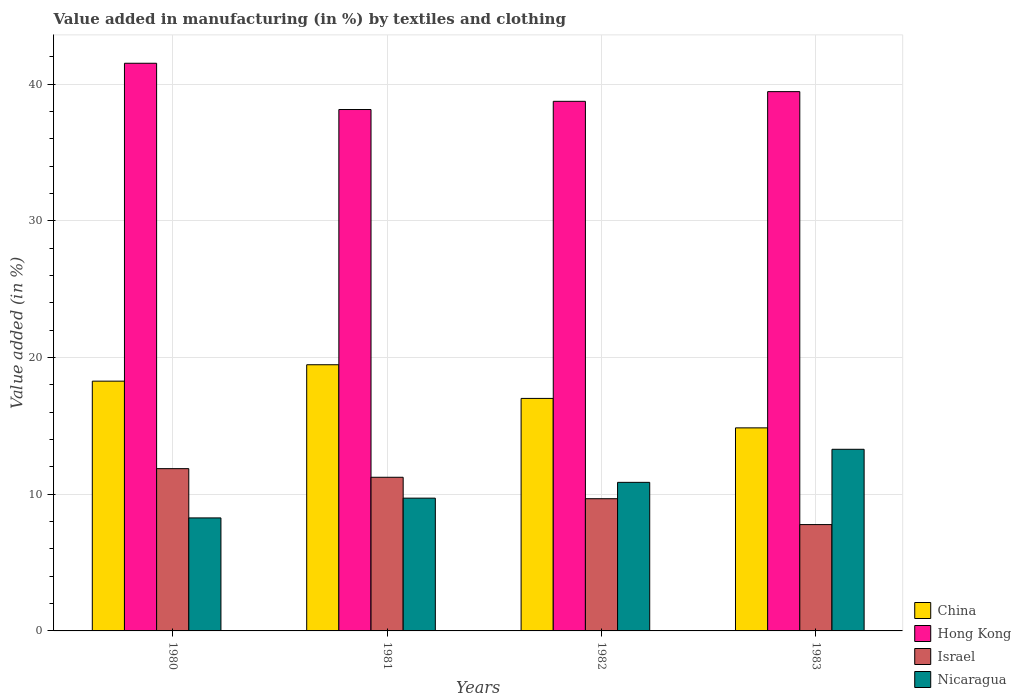How many different coloured bars are there?
Provide a short and direct response. 4. Are the number of bars on each tick of the X-axis equal?
Offer a terse response. Yes. How many bars are there on the 1st tick from the right?
Provide a succinct answer. 4. What is the label of the 1st group of bars from the left?
Offer a terse response. 1980. What is the percentage of value added in manufacturing by textiles and clothing in Nicaragua in 1983?
Make the answer very short. 13.29. Across all years, what is the maximum percentage of value added in manufacturing by textiles and clothing in Nicaragua?
Your answer should be very brief. 13.29. Across all years, what is the minimum percentage of value added in manufacturing by textiles and clothing in Israel?
Offer a terse response. 7.78. In which year was the percentage of value added in manufacturing by textiles and clothing in China maximum?
Give a very brief answer. 1981. In which year was the percentage of value added in manufacturing by textiles and clothing in Hong Kong minimum?
Offer a very short reply. 1981. What is the total percentage of value added in manufacturing by textiles and clothing in Israel in the graph?
Provide a short and direct response. 40.57. What is the difference between the percentage of value added in manufacturing by textiles and clothing in Israel in 1982 and that in 1983?
Provide a short and direct response. 1.89. What is the difference between the percentage of value added in manufacturing by textiles and clothing in Nicaragua in 1982 and the percentage of value added in manufacturing by textiles and clothing in Hong Kong in 1980?
Ensure brevity in your answer.  -30.66. What is the average percentage of value added in manufacturing by textiles and clothing in Israel per year?
Your answer should be very brief. 10.14. In the year 1981, what is the difference between the percentage of value added in manufacturing by textiles and clothing in Hong Kong and percentage of value added in manufacturing by textiles and clothing in Nicaragua?
Offer a terse response. 28.43. What is the ratio of the percentage of value added in manufacturing by textiles and clothing in Israel in 1982 to that in 1983?
Ensure brevity in your answer.  1.24. What is the difference between the highest and the second highest percentage of value added in manufacturing by textiles and clothing in Hong Kong?
Give a very brief answer. 2.08. What is the difference between the highest and the lowest percentage of value added in manufacturing by textiles and clothing in Nicaragua?
Keep it short and to the point. 5.02. In how many years, is the percentage of value added in manufacturing by textiles and clothing in Israel greater than the average percentage of value added in manufacturing by textiles and clothing in Israel taken over all years?
Give a very brief answer. 2. Is the sum of the percentage of value added in manufacturing by textiles and clothing in Israel in 1980 and 1981 greater than the maximum percentage of value added in manufacturing by textiles and clothing in Nicaragua across all years?
Your answer should be compact. Yes. Is it the case that in every year, the sum of the percentage of value added in manufacturing by textiles and clothing in China and percentage of value added in manufacturing by textiles and clothing in Hong Kong is greater than the sum of percentage of value added in manufacturing by textiles and clothing in Israel and percentage of value added in manufacturing by textiles and clothing in Nicaragua?
Your answer should be compact. Yes. What does the 1st bar from the left in 1982 represents?
Keep it short and to the point. China. What does the 2nd bar from the right in 1980 represents?
Offer a terse response. Israel. How many bars are there?
Provide a succinct answer. 16. How many years are there in the graph?
Offer a terse response. 4. Does the graph contain any zero values?
Offer a terse response. No. Does the graph contain grids?
Offer a terse response. Yes. Where does the legend appear in the graph?
Provide a succinct answer. Bottom right. How many legend labels are there?
Ensure brevity in your answer.  4. What is the title of the graph?
Provide a short and direct response. Value added in manufacturing (in %) by textiles and clothing. What is the label or title of the Y-axis?
Offer a very short reply. Value added (in %). What is the Value added (in %) of China in 1980?
Provide a short and direct response. 18.27. What is the Value added (in %) of Hong Kong in 1980?
Make the answer very short. 41.53. What is the Value added (in %) of Israel in 1980?
Offer a terse response. 11.87. What is the Value added (in %) of Nicaragua in 1980?
Keep it short and to the point. 8.27. What is the Value added (in %) of China in 1981?
Provide a succinct answer. 19.47. What is the Value added (in %) of Hong Kong in 1981?
Make the answer very short. 38.15. What is the Value added (in %) in Israel in 1981?
Give a very brief answer. 11.24. What is the Value added (in %) in Nicaragua in 1981?
Provide a short and direct response. 9.71. What is the Value added (in %) in China in 1982?
Your response must be concise. 17.01. What is the Value added (in %) of Hong Kong in 1982?
Give a very brief answer. 38.75. What is the Value added (in %) of Israel in 1982?
Your response must be concise. 9.67. What is the Value added (in %) in Nicaragua in 1982?
Keep it short and to the point. 10.87. What is the Value added (in %) of China in 1983?
Keep it short and to the point. 14.86. What is the Value added (in %) in Hong Kong in 1983?
Provide a short and direct response. 39.46. What is the Value added (in %) in Israel in 1983?
Offer a terse response. 7.78. What is the Value added (in %) in Nicaragua in 1983?
Your answer should be very brief. 13.29. Across all years, what is the maximum Value added (in %) of China?
Your answer should be very brief. 19.47. Across all years, what is the maximum Value added (in %) of Hong Kong?
Your answer should be very brief. 41.53. Across all years, what is the maximum Value added (in %) of Israel?
Your answer should be very brief. 11.87. Across all years, what is the maximum Value added (in %) in Nicaragua?
Your response must be concise. 13.29. Across all years, what is the minimum Value added (in %) in China?
Offer a very short reply. 14.86. Across all years, what is the minimum Value added (in %) in Hong Kong?
Provide a succinct answer. 38.15. Across all years, what is the minimum Value added (in %) of Israel?
Give a very brief answer. 7.78. Across all years, what is the minimum Value added (in %) in Nicaragua?
Ensure brevity in your answer.  8.27. What is the total Value added (in %) of China in the graph?
Your response must be concise. 69.61. What is the total Value added (in %) of Hong Kong in the graph?
Give a very brief answer. 157.88. What is the total Value added (in %) in Israel in the graph?
Offer a terse response. 40.57. What is the total Value added (in %) in Nicaragua in the graph?
Give a very brief answer. 42.14. What is the difference between the Value added (in %) of China in 1980 and that in 1981?
Your answer should be very brief. -1.2. What is the difference between the Value added (in %) of Hong Kong in 1980 and that in 1981?
Make the answer very short. 3.38. What is the difference between the Value added (in %) in Israel in 1980 and that in 1981?
Provide a short and direct response. 0.63. What is the difference between the Value added (in %) of Nicaragua in 1980 and that in 1981?
Provide a short and direct response. -1.45. What is the difference between the Value added (in %) in China in 1980 and that in 1982?
Your answer should be compact. 1.26. What is the difference between the Value added (in %) of Hong Kong in 1980 and that in 1982?
Keep it short and to the point. 2.78. What is the difference between the Value added (in %) in Israel in 1980 and that in 1982?
Keep it short and to the point. 2.2. What is the difference between the Value added (in %) in Nicaragua in 1980 and that in 1982?
Your answer should be very brief. -2.6. What is the difference between the Value added (in %) in China in 1980 and that in 1983?
Give a very brief answer. 3.42. What is the difference between the Value added (in %) in Hong Kong in 1980 and that in 1983?
Provide a succinct answer. 2.08. What is the difference between the Value added (in %) of Israel in 1980 and that in 1983?
Give a very brief answer. 4.09. What is the difference between the Value added (in %) of Nicaragua in 1980 and that in 1983?
Your answer should be compact. -5.02. What is the difference between the Value added (in %) in China in 1981 and that in 1982?
Make the answer very short. 2.46. What is the difference between the Value added (in %) of Hong Kong in 1981 and that in 1982?
Offer a very short reply. -0.6. What is the difference between the Value added (in %) of Israel in 1981 and that in 1982?
Make the answer very short. 1.57. What is the difference between the Value added (in %) of Nicaragua in 1981 and that in 1982?
Provide a short and direct response. -1.16. What is the difference between the Value added (in %) in China in 1981 and that in 1983?
Keep it short and to the point. 4.62. What is the difference between the Value added (in %) of Hong Kong in 1981 and that in 1983?
Provide a short and direct response. -1.31. What is the difference between the Value added (in %) in Israel in 1981 and that in 1983?
Offer a terse response. 3.46. What is the difference between the Value added (in %) of Nicaragua in 1981 and that in 1983?
Your answer should be compact. -3.57. What is the difference between the Value added (in %) in China in 1982 and that in 1983?
Offer a very short reply. 2.16. What is the difference between the Value added (in %) in Hong Kong in 1982 and that in 1983?
Provide a succinct answer. -0.71. What is the difference between the Value added (in %) in Israel in 1982 and that in 1983?
Offer a very short reply. 1.89. What is the difference between the Value added (in %) of Nicaragua in 1982 and that in 1983?
Give a very brief answer. -2.42. What is the difference between the Value added (in %) in China in 1980 and the Value added (in %) in Hong Kong in 1981?
Your answer should be very brief. -19.87. What is the difference between the Value added (in %) in China in 1980 and the Value added (in %) in Israel in 1981?
Your answer should be very brief. 7.03. What is the difference between the Value added (in %) in China in 1980 and the Value added (in %) in Nicaragua in 1981?
Provide a short and direct response. 8.56. What is the difference between the Value added (in %) in Hong Kong in 1980 and the Value added (in %) in Israel in 1981?
Make the answer very short. 30.29. What is the difference between the Value added (in %) of Hong Kong in 1980 and the Value added (in %) of Nicaragua in 1981?
Offer a very short reply. 31.82. What is the difference between the Value added (in %) in Israel in 1980 and the Value added (in %) in Nicaragua in 1981?
Make the answer very short. 2.16. What is the difference between the Value added (in %) in China in 1980 and the Value added (in %) in Hong Kong in 1982?
Provide a short and direct response. -20.47. What is the difference between the Value added (in %) of China in 1980 and the Value added (in %) of Israel in 1982?
Offer a very short reply. 8.6. What is the difference between the Value added (in %) in China in 1980 and the Value added (in %) in Nicaragua in 1982?
Offer a terse response. 7.4. What is the difference between the Value added (in %) in Hong Kong in 1980 and the Value added (in %) in Israel in 1982?
Keep it short and to the point. 31.86. What is the difference between the Value added (in %) in Hong Kong in 1980 and the Value added (in %) in Nicaragua in 1982?
Your response must be concise. 30.66. What is the difference between the Value added (in %) of China in 1980 and the Value added (in %) of Hong Kong in 1983?
Ensure brevity in your answer.  -21.18. What is the difference between the Value added (in %) of China in 1980 and the Value added (in %) of Israel in 1983?
Your response must be concise. 10.49. What is the difference between the Value added (in %) in China in 1980 and the Value added (in %) in Nicaragua in 1983?
Keep it short and to the point. 4.99. What is the difference between the Value added (in %) in Hong Kong in 1980 and the Value added (in %) in Israel in 1983?
Your answer should be compact. 33.75. What is the difference between the Value added (in %) in Hong Kong in 1980 and the Value added (in %) in Nicaragua in 1983?
Ensure brevity in your answer.  28.24. What is the difference between the Value added (in %) in Israel in 1980 and the Value added (in %) in Nicaragua in 1983?
Offer a terse response. -1.42. What is the difference between the Value added (in %) in China in 1981 and the Value added (in %) in Hong Kong in 1982?
Provide a short and direct response. -19.27. What is the difference between the Value added (in %) in China in 1981 and the Value added (in %) in Israel in 1982?
Make the answer very short. 9.8. What is the difference between the Value added (in %) of China in 1981 and the Value added (in %) of Nicaragua in 1982?
Your response must be concise. 8.6. What is the difference between the Value added (in %) of Hong Kong in 1981 and the Value added (in %) of Israel in 1982?
Offer a very short reply. 28.47. What is the difference between the Value added (in %) in Hong Kong in 1981 and the Value added (in %) in Nicaragua in 1982?
Your answer should be very brief. 27.28. What is the difference between the Value added (in %) of Israel in 1981 and the Value added (in %) of Nicaragua in 1982?
Give a very brief answer. 0.37. What is the difference between the Value added (in %) in China in 1981 and the Value added (in %) in Hong Kong in 1983?
Your answer should be very brief. -19.98. What is the difference between the Value added (in %) in China in 1981 and the Value added (in %) in Israel in 1983?
Offer a very short reply. 11.69. What is the difference between the Value added (in %) in China in 1981 and the Value added (in %) in Nicaragua in 1983?
Give a very brief answer. 6.19. What is the difference between the Value added (in %) in Hong Kong in 1981 and the Value added (in %) in Israel in 1983?
Give a very brief answer. 30.37. What is the difference between the Value added (in %) of Hong Kong in 1981 and the Value added (in %) of Nicaragua in 1983?
Your answer should be compact. 24.86. What is the difference between the Value added (in %) of Israel in 1981 and the Value added (in %) of Nicaragua in 1983?
Offer a very short reply. -2.05. What is the difference between the Value added (in %) in China in 1982 and the Value added (in %) in Hong Kong in 1983?
Give a very brief answer. -22.44. What is the difference between the Value added (in %) in China in 1982 and the Value added (in %) in Israel in 1983?
Offer a very short reply. 9.23. What is the difference between the Value added (in %) of China in 1982 and the Value added (in %) of Nicaragua in 1983?
Ensure brevity in your answer.  3.72. What is the difference between the Value added (in %) in Hong Kong in 1982 and the Value added (in %) in Israel in 1983?
Provide a short and direct response. 30.97. What is the difference between the Value added (in %) of Hong Kong in 1982 and the Value added (in %) of Nicaragua in 1983?
Provide a succinct answer. 25.46. What is the difference between the Value added (in %) of Israel in 1982 and the Value added (in %) of Nicaragua in 1983?
Provide a short and direct response. -3.62. What is the average Value added (in %) in China per year?
Provide a short and direct response. 17.4. What is the average Value added (in %) of Hong Kong per year?
Keep it short and to the point. 39.47. What is the average Value added (in %) in Israel per year?
Give a very brief answer. 10.14. What is the average Value added (in %) in Nicaragua per year?
Offer a very short reply. 10.53. In the year 1980, what is the difference between the Value added (in %) in China and Value added (in %) in Hong Kong?
Provide a short and direct response. -23.26. In the year 1980, what is the difference between the Value added (in %) in China and Value added (in %) in Israel?
Offer a very short reply. 6.4. In the year 1980, what is the difference between the Value added (in %) of China and Value added (in %) of Nicaragua?
Ensure brevity in your answer.  10.01. In the year 1980, what is the difference between the Value added (in %) of Hong Kong and Value added (in %) of Israel?
Provide a short and direct response. 29.66. In the year 1980, what is the difference between the Value added (in %) of Hong Kong and Value added (in %) of Nicaragua?
Make the answer very short. 33.26. In the year 1980, what is the difference between the Value added (in %) of Israel and Value added (in %) of Nicaragua?
Your answer should be very brief. 3.6. In the year 1981, what is the difference between the Value added (in %) in China and Value added (in %) in Hong Kong?
Make the answer very short. -18.67. In the year 1981, what is the difference between the Value added (in %) in China and Value added (in %) in Israel?
Keep it short and to the point. 8.23. In the year 1981, what is the difference between the Value added (in %) of China and Value added (in %) of Nicaragua?
Offer a very short reply. 9.76. In the year 1981, what is the difference between the Value added (in %) of Hong Kong and Value added (in %) of Israel?
Your response must be concise. 26.91. In the year 1981, what is the difference between the Value added (in %) of Hong Kong and Value added (in %) of Nicaragua?
Give a very brief answer. 28.43. In the year 1981, what is the difference between the Value added (in %) in Israel and Value added (in %) in Nicaragua?
Provide a succinct answer. 1.53. In the year 1982, what is the difference between the Value added (in %) of China and Value added (in %) of Hong Kong?
Ensure brevity in your answer.  -21.74. In the year 1982, what is the difference between the Value added (in %) of China and Value added (in %) of Israel?
Provide a short and direct response. 7.34. In the year 1982, what is the difference between the Value added (in %) of China and Value added (in %) of Nicaragua?
Your answer should be very brief. 6.14. In the year 1982, what is the difference between the Value added (in %) in Hong Kong and Value added (in %) in Israel?
Make the answer very short. 29.07. In the year 1982, what is the difference between the Value added (in %) in Hong Kong and Value added (in %) in Nicaragua?
Give a very brief answer. 27.88. In the year 1982, what is the difference between the Value added (in %) in Israel and Value added (in %) in Nicaragua?
Give a very brief answer. -1.2. In the year 1983, what is the difference between the Value added (in %) of China and Value added (in %) of Hong Kong?
Provide a short and direct response. -24.6. In the year 1983, what is the difference between the Value added (in %) of China and Value added (in %) of Israel?
Make the answer very short. 7.08. In the year 1983, what is the difference between the Value added (in %) in China and Value added (in %) in Nicaragua?
Provide a succinct answer. 1.57. In the year 1983, what is the difference between the Value added (in %) of Hong Kong and Value added (in %) of Israel?
Offer a very short reply. 31.68. In the year 1983, what is the difference between the Value added (in %) in Hong Kong and Value added (in %) in Nicaragua?
Provide a succinct answer. 26.17. In the year 1983, what is the difference between the Value added (in %) in Israel and Value added (in %) in Nicaragua?
Your answer should be compact. -5.51. What is the ratio of the Value added (in %) of China in 1980 to that in 1981?
Offer a very short reply. 0.94. What is the ratio of the Value added (in %) in Hong Kong in 1980 to that in 1981?
Keep it short and to the point. 1.09. What is the ratio of the Value added (in %) of Israel in 1980 to that in 1981?
Offer a terse response. 1.06. What is the ratio of the Value added (in %) of Nicaragua in 1980 to that in 1981?
Ensure brevity in your answer.  0.85. What is the ratio of the Value added (in %) of China in 1980 to that in 1982?
Make the answer very short. 1.07. What is the ratio of the Value added (in %) of Hong Kong in 1980 to that in 1982?
Make the answer very short. 1.07. What is the ratio of the Value added (in %) of Israel in 1980 to that in 1982?
Your answer should be compact. 1.23. What is the ratio of the Value added (in %) in Nicaragua in 1980 to that in 1982?
Your answer should be compact. 0.76. What is the ratio of the Value added (in %) in China in 1980 to that in 1983?
Your response must be concise. 1.23. What is the ratio of the Value added (in %) of Hong Kong in 1980 to that in 1983?
Ensure brevity in your answer.  1.05. What is the ratio of the Value added (in %) of Israel in 1980 to that in 1983?
Your answer should be very brief. 1.53. What is the ratio of the Value added (in %) in Nicaragua in 1980 to that in 1983?
Offer a very short reply. 0.62. What is the ratio of the Value added (in %) of China in 1981 to that in 1982?
Make the answer very short. 1.14. What is the ratio of the Value added (in %) of Hong Kong in 1981 to that in 1982?
Your answer should be compact. 0.98. What is the ratio of the Value added (in %) of Israel in 1981 to that in 1982?
Your response must be concise. 1.16. What is the ratio of the Value added (in %) in Nicaragua in 1981 to that in 1982?
Your answer should be very brief. 0.89. What is the ratio of the Value added (in %) in China in 1981 to that in 1983?
Provide a succinct answer. 1.31. What is the ratio of the Value added (in %) in Hong Kong in 1981 to that in 1983?
Offer a very short reply. 0.97. What is the ratio of the Value added (in %) in Israel in 1981 to that in 1983?
Your answer should be compact. 1.44. What is the ratio of the Value added (in %) of Nicaragua in 1981 to that in 1983?
Make the answer very short. 0.73. What is the ratio of the Value added (in %) in China in 1982 to that in 1983?
Your answer should be compact. 1.15. What is the ratio of the Value added (in %) of Israel in 1982 to that in 1983?
Your answer should be compact. 1.24. What is the ratio of the Value added (in %) of Nicaragua in 1982 to that in 1983?
Make the answer very short. 0.82. What is the difference between the highest and the second highest Value added (in %) of China?
Offer a terse response. 1.2. What is the difference between the highest and the second highest Value added (in %) of Hong Kong?
Your response must be concise. 2.08. What is the difference between the highest and the second highest Value added (in %) in Israel?
Your response must be concise. 0.63. What is the difference between the highest and the second highest Value added (in %) of Nicaragua?
Your answer should be compact. 2.42. What is the difference between the highest and the lowest Value added (in %) of China?
Provide a short and direct response. 4.62. What is the difference between the highest and the lowest Value added (in %) of Hong Kong?
Your answer should be compact. 3.38. What is the difference between the highest and the lowest Value added (in %) of Israel?
Keep it short and to the point. 4.09. What is the difference between the highest and the lowest Value added (in %) in Nicaragua?
Your response must be concise. 5.02. 